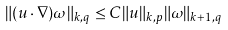<formula> <loc_0><loc_0><loc_500><loc_500>\| ( u \cdot \nabla ) \omega \| _ { k , q } \leq C \| u \| _ { k , p } \| \omega \| _ { k + 1 , q }</formula> 